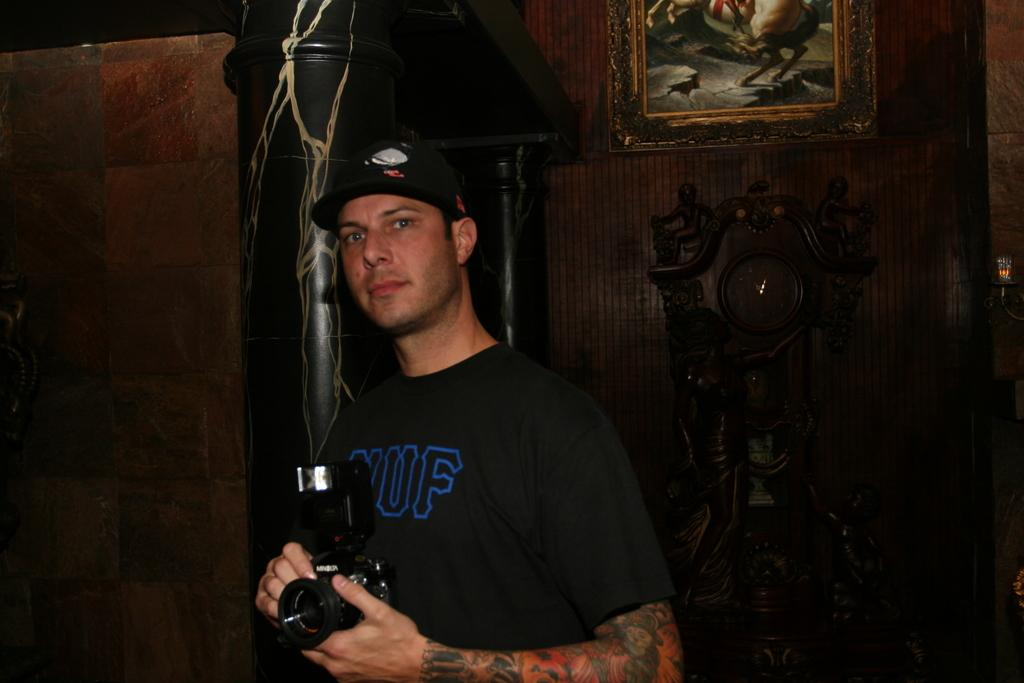What is happening in the image involving a person? The person in the image is catching a camera. What can be seen in the background of the image? There is a wall in the image, and on that wall, there is a frame. Can you describe the action of the person in the image? The person is catching a camera, which suggests that it may have been dropped or thrown. What type of zipper can be seen on the person's clothing in the image? There is no zipper visible on the person's clothing in the image. Does the person have a tail in the image? No, the person does not have a tail in the image. 